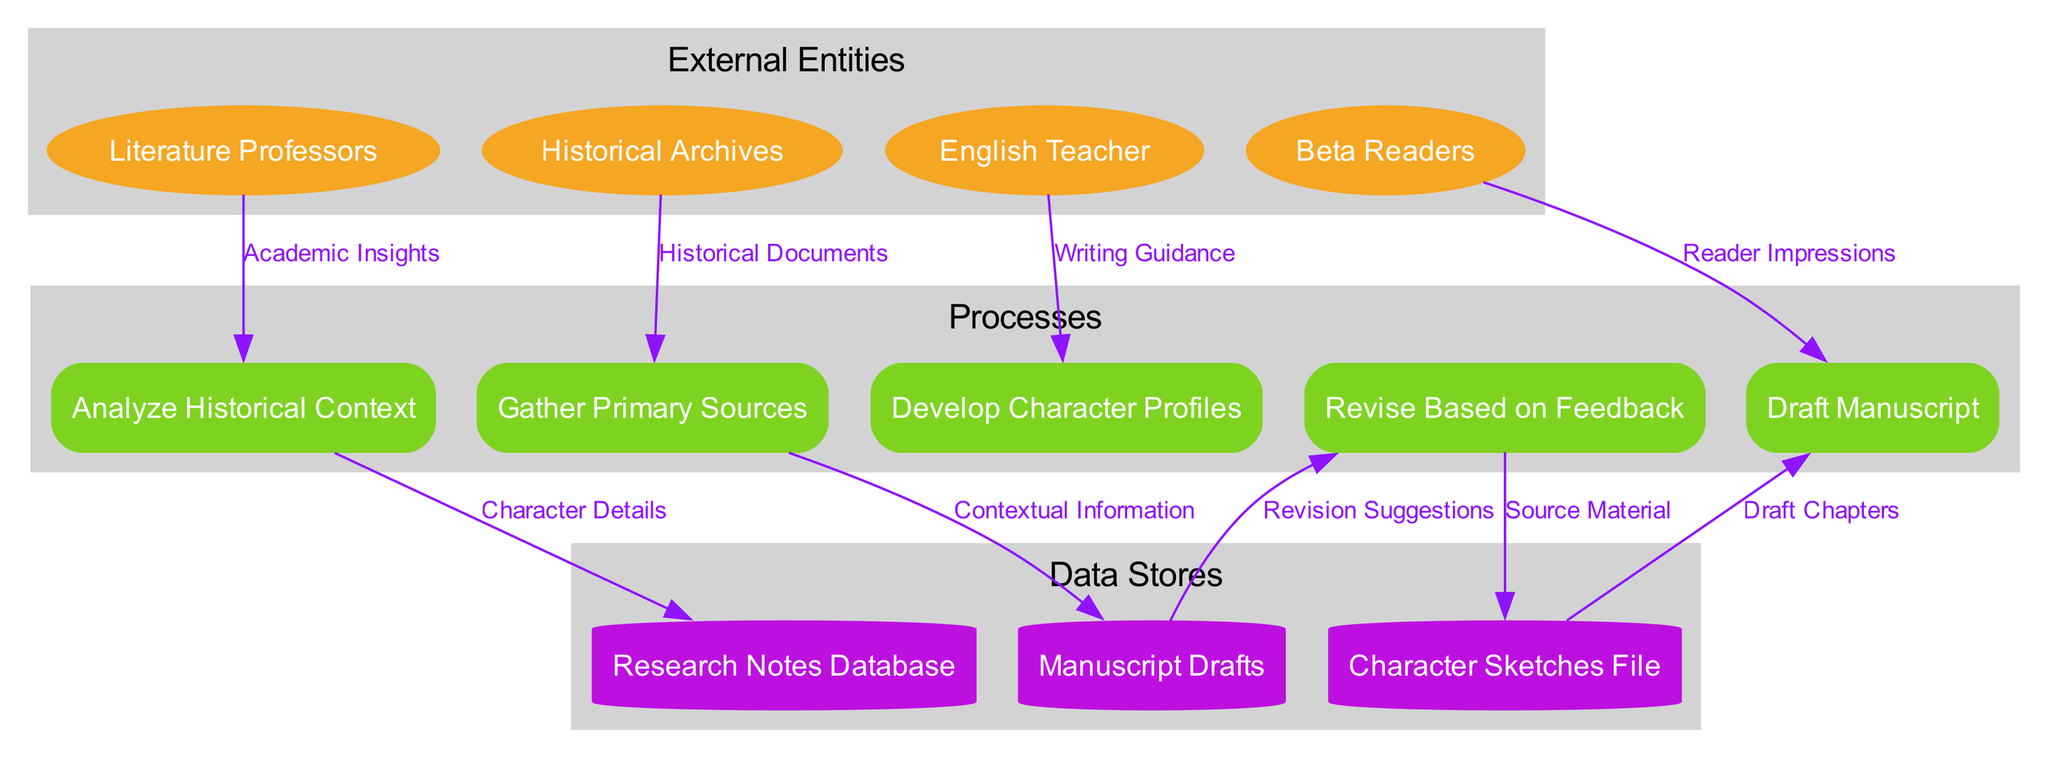What is the first process in the diagram? The first process listed in the diagram is "Gather Primary Sources," which is the top node in the Processes section.
Answer: Gather Primary Sources How many external entities are present? There are four external entities listed in the diagram: Historical Archives, Literature Professors, English Teacher, and Beta Readers. By counting them, we find a total of four.
Answer: 4 What type of node represents the character profiles? The character profiles are found in a data store labeled "Character Sketches File," which is represented as a cylinder in the diagram.
Answer: Cylinder Which external entity provides writing guidance? The external entity that provides writing guidance is "English Teacher," as indicated by the edges connecting it to the relevant processes in the diagram.
Answer: English Teacher What process receives academic insights? The process "Analyze Historical Context" receives academic insights according to the flow direction from "Literature Professors" to that process.
Answer: Analyze Historical Context Which data flow connects the "Draft Manuscript" process to a data store? The data flow that connects "Draft Manuscript" to a data store is "Draft Chapters," which leads from the process to the "Manuscript Drafts" data store.
Answer: Draft Chapters What is the total number of processes in the diagram? The total number of processes in the diagram is five, which includes "Gather Primary Sources," "Analyze Historical Context," "Develop Character Profiles," "Draft Manuscript," and "Revise Based on Feedback."
Answer: 5 What data store does the "Revise Based on Feedback" process pull from? The "Revise Based on Feedback" process pulls from the "Manuscript Drafts" data store, as the diagram shows an edge connecting to that store.
Answer: Manuscript Drafts How many data flows are shown between external entities and processes? There are four data flows shown between external entities and processes, corresponding to the four external entities connected to the processes in the diagram.
Answer: 4 